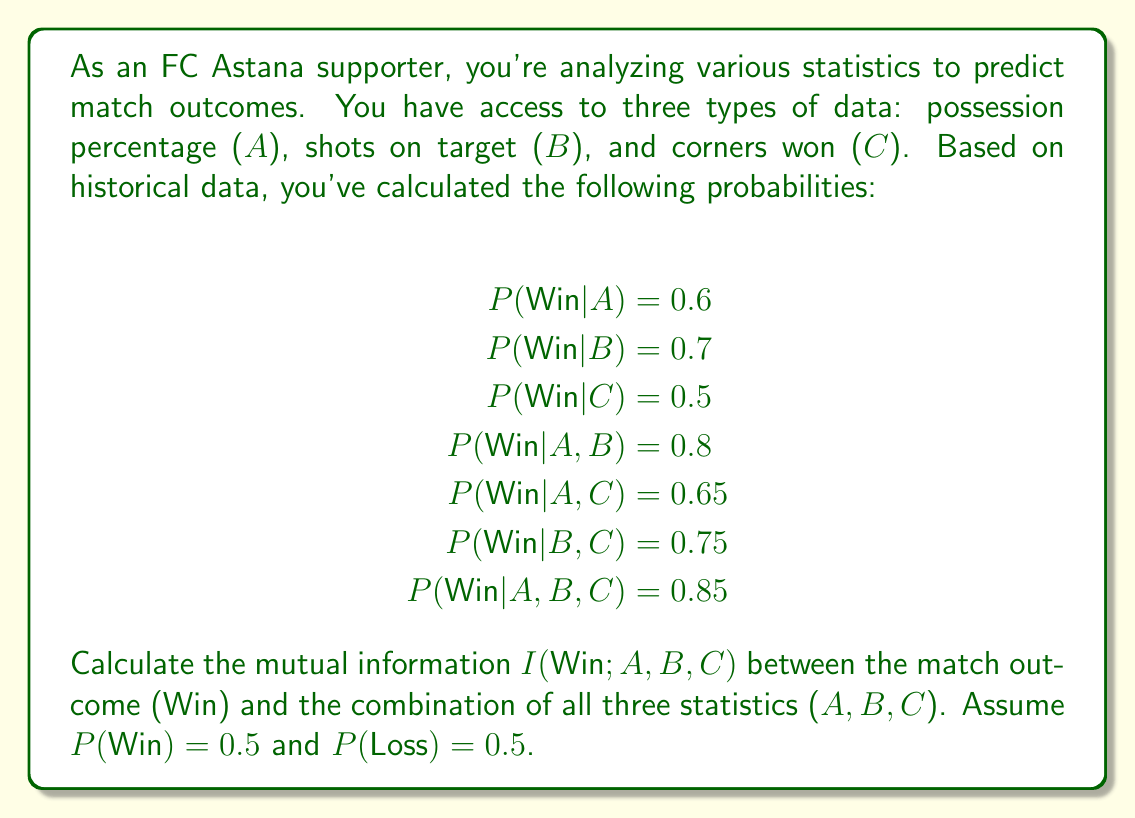Could you help me with this problem? To calculate the mutual information I(Win;A,B,C), we need to use the formula:

$$I(Win;A,B,C) = H(Win) - H(Win|A,B,C)$$

Where H(Win) is the entropy of the match outcome, and H(Win|A,B,C) is the conditional entropy of the match outcome given all three statistics.

Step 1: Calculate H(Win)
$$H(Win) = -\sum_{i} P(i) \log_2 P(i)$$
$$H(Win) = -[0.5 \log_2 0.5 + 0.5 \log_2 0.5] = 1 \text{ bit}$$

Step 2: Calculate H(Win|A,B,C)
$$H(Win|A,B,C) = -[P(Win|A,B,C) \log_2 P(Win|A,B,C) + P(Loss|A,B,C) \log_2 P(Loss|A,B,C)]$$
$$H(Win|A,B,C) = -[0.85 \log_2 0.85 + 0.15 \log_2 0.15]$$
$$H(Win|A,B,C) \approx 0.6098 \text{ bits}$$

Step 3: Calculate I(Win;A,B,C)
$$I(Win;A,B,C) = H(Win) - H(Win|A,B,C)$$
$$I(Win;A,B,C) = 1 - 0.6098 \approx 0.3902 \text{ bits}$$

This result indicates that knowing all three statistics (possession percentage, shots on target, and corners won) provides approximately 0.3902 bits of information about the match outcome.
Answer: The mutual information I(Win;A,B,C) between the match outcome (Win) and the combination of all three statistics (A,B,C) is approximately 0.3902 bits. 